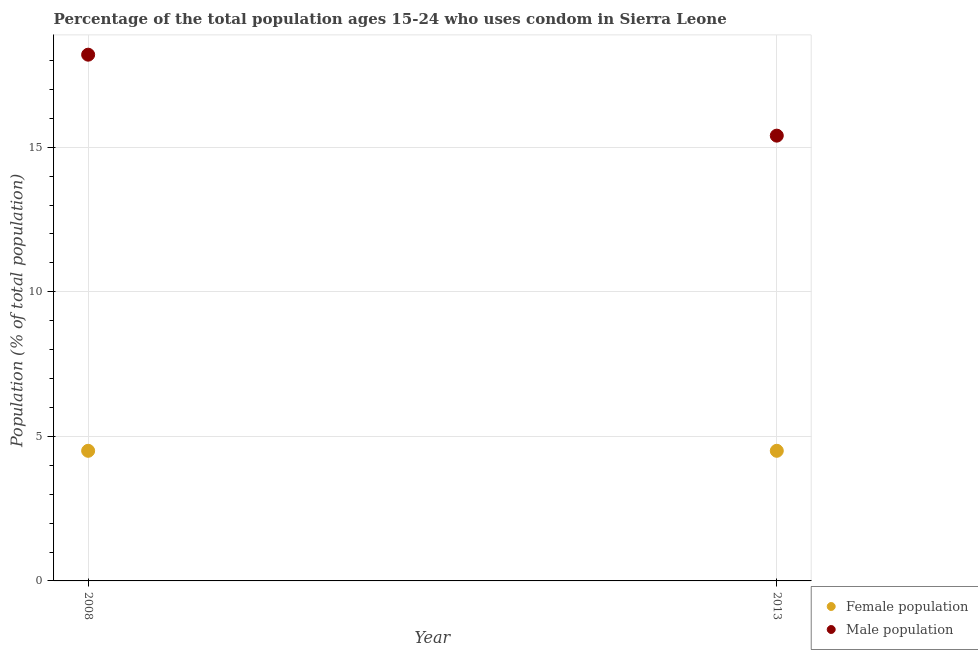Is the number of dotlines equal to the number of legend labels?
Offer a terse response. Yes. Across all years, what is the maximum male population?
Your answer should be very brief. 18.2. What is the difference between the female population in 2008 and that in 2013?
Provide a succinct answer. 0. What is the difference between the female population in 2013 and the male population in 2008?
Keep it short and to the point. -13.7. In how many years, is the male population greater than 7 %?
Your response must be concise. 2. What is the ratio of the female population in 2008 to that in 2013?
Keep it short and to the point. 1. Is the male population in 2008 less than that in 2013?
Your answer should be compact. No. Where does the legend appear in the graph?
Offer a terse response. Bottom right. What is the title of the graph?
Ensure brevity in your answer.  Percentage of the total population ages 15-24 who uses condom in Sierra Leone. What is the label or title of the X-axis?
Provide a short and direct response. Year. What is the label or title of the Y-axis?
Your answer should be compact. Population (% of total population) . What is the Population (% of total population)  of Male population in 2008?
Your response must be concise. 18.2. What is the Population (% of total population)  of Female population in 2013?
Ensure brevity in your answer.  4.5. Across all years, what is the maximum Population (% of total population)  of Female population?
Ensure brevity in your answer.  4.5. Across all years, what is the maximum Population (% of total population)  in Male population?
Your answer should be compact. 18.2. Across all years, what is the minimum Population (% of total population)  in Female population?
Provide a short and direct response. 4.5. What is the total Population (% of total population)  in Male population in the graph?
Your response must be concise. 33.6. What is the average Population (% of total population)  of Female population per year?
Provide a succinct answer. 4.5. What is the average Population (% of total population)  in Male population per year?
Your answer should be compact. 16.8. In the year 2008, what is the difference between the Population (% of total population)  in Female population and Population (% of total population)  in Male population?
Your response must be concise. -13.7. In the year 2013, what is the difference between the Population (% of total population)  in Female population and Population (% of total population)  in Male population?
Offer a terse response. -10.9. What is the ratio of the Population (% of total population)  of Male population in 2008 to that in 2013?
Offer a terse response. 1.18. What is the difference between the highest and the second highest Population (% of total population)  in Female population?
Provide a short and direct response. 0. What is the difference between the highest and the second highest Population (% of total population)  of Male population?
Offer a very short reply. 2.8. 